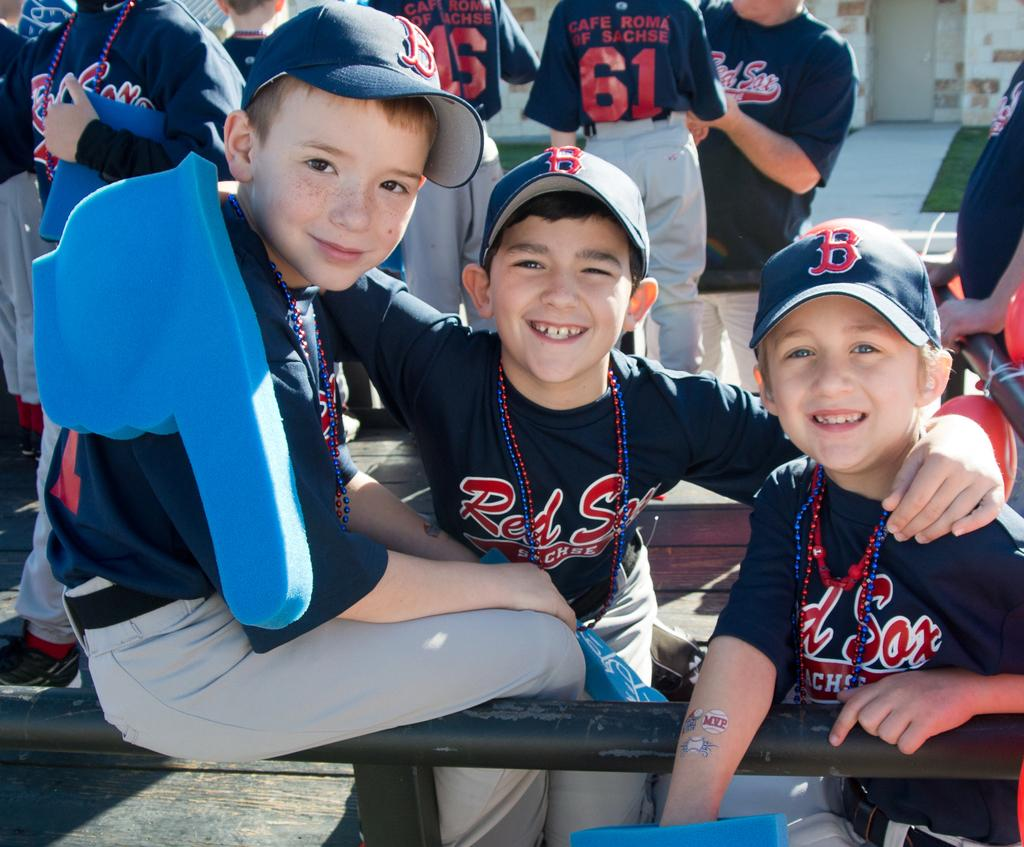<image>
Offer a succinct explanation of the picture presented. Boys in Red Sox shirts gather up for a photo. 